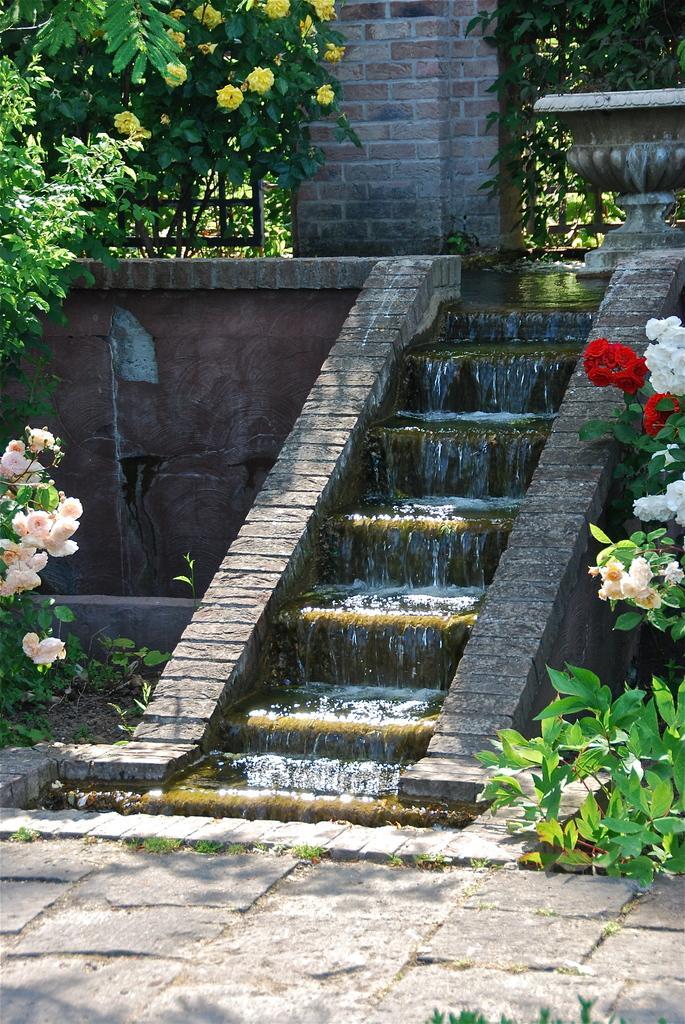Can you describe this image briefly? In this picture we can see trees, flowers, path, steps, water, wall, fence. 